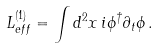Convert formula to latex. <formula><loc_0><loc_0><loc_500><loc_500>L ^ { ( 1 ) } _ { e f f } = \int d ^ { 2 } x \, i \phi ^ { \dagger } \partial _ { t } \phi \, .</formula> 